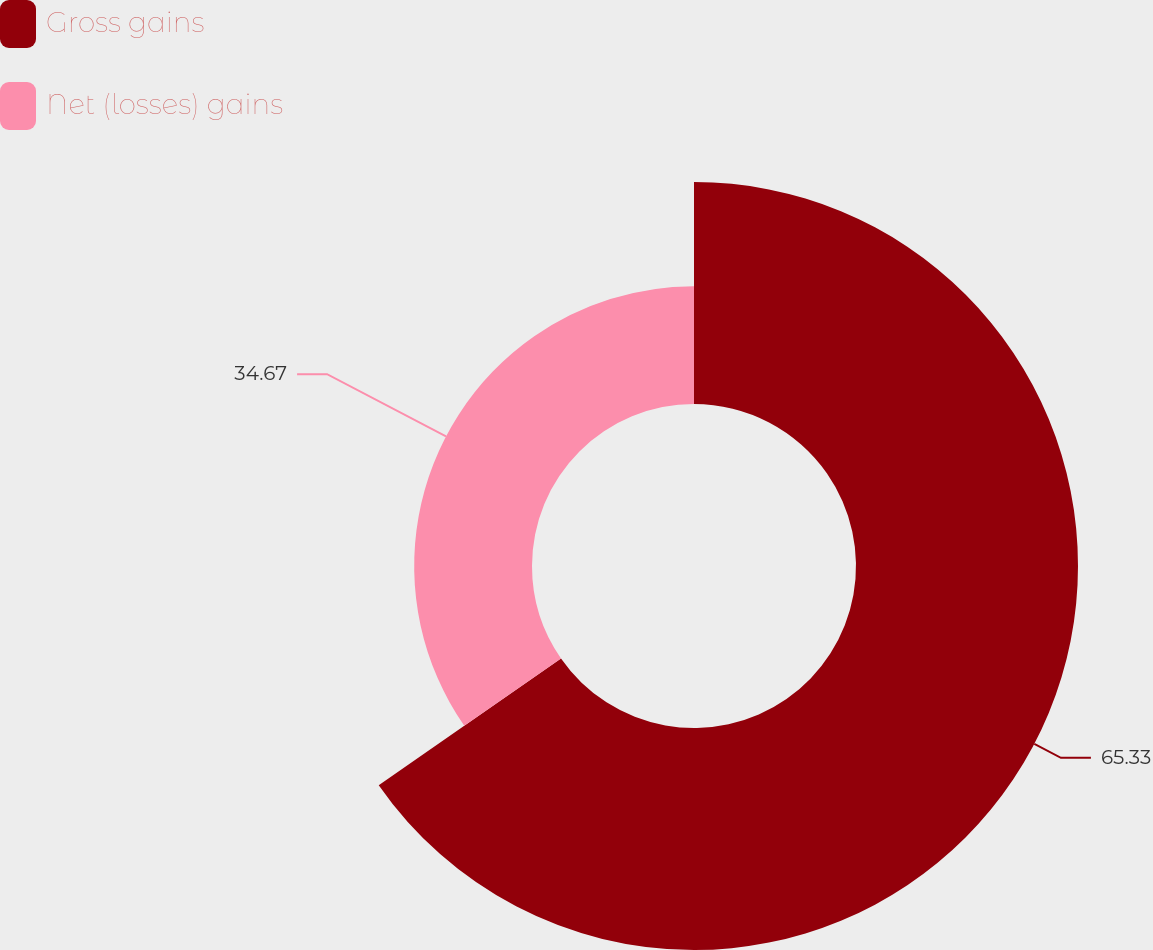Convert chart to OTSL. <chart><loc_0><loc_0><loc_500><loc_500><pie_chart><fcel>Gross gains<fcel>Net (losses) gains<nl><fcel>65.33%<fcel>34.67%<nl></chart> 